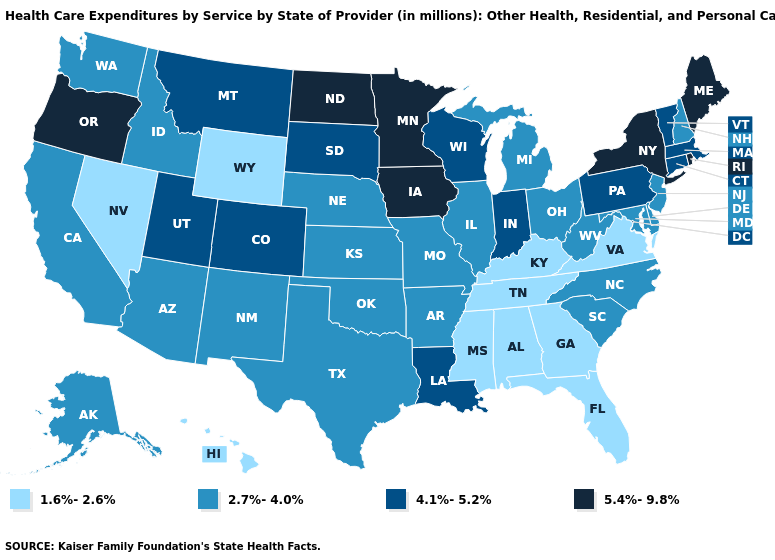What is the value of New York?
Concise answer only. 5.4%-9.8%. Does Nebraska have a higher value than New York?
Write a very short answer. No. Name the states that have a value in the range 5.4%-9.8%?
Short answer required. Iowa, Maine, Minnesota, New York, North Dakota, Oregon, Rhode Island. What is the value of Wisconsin?
Short answer required. 4.1%-5.2%. Among the states that border Nevada , does Oregon have the highest value?
Write a very short answer. Yes. What is the value of Wisconsin?
Answer briefly. 4.1%-5.2%. Does Vermont have the lowest value in the Northeast?
Quick response, please. No. What is the value of Hawaii?
Answer briefly. 1.6%-2.6%. Name the states that have a value in the range 4.1%-5.2%?
Keep it brief. Colorado, Connecticut, Indiana, Louisiana, Massachusetts, Montana, Pennsylvania, South Dakota, Utah, Vermont, Wisconsin. Name the states that have a value in the range 1.6%-2.6%?
Concise answer only. Alabama, Florida, Georgia, Hawaii, Kentucky, Mississippi, Nevada, Tennessee, Virginia, Wyoming. Which states have the lowest value in the South?
Write a very short answer. Alabama, Florida, Georgia, Kentucky, Mississippi, Tennessee, Virginia. Name the states that have a value in the range 2.7%-4.0%?
Concise answer only. Alaska, Arizona, Arkansas, California, Delaware, Idaho, Illinois, Kansas, Maryland, Michigan, Missouri, Nebraska, New Hampshire, New Jersey, New Mexico, North Carolina, Ohio, Oklahoma, South Carolina, Texas, Washington, West Virginia. Name the states that have a value in the range 2.7%-4.0%?
Give a very brief answer. Alaska, Arizona, Arkansas, California, Delaware, Idaho, Illinois, Kansas, Maryland, Michigan, Missouri, Nebraska, New Hampshire, New Jersey, New Mexico, North Carolina, Ohio, Oklahoma, South Carolina, Texas, Washington, West Virginia. Name the states that have a value in the range 1.6%-2.6%?
Quick response, please. Alabama, Florida, Georgia, Hawaii, Kentucky, Mississippi, Nevada, Tennessee, Virginia, Wyoming. Name the states that have a value in the range 1.6%-2.6%?
Write a very short answer. Alabama, Florida, Georgia, Hawaii, Kentucky, Mississippi, Nevada, Tennessee, Virginia, Wyoming. 